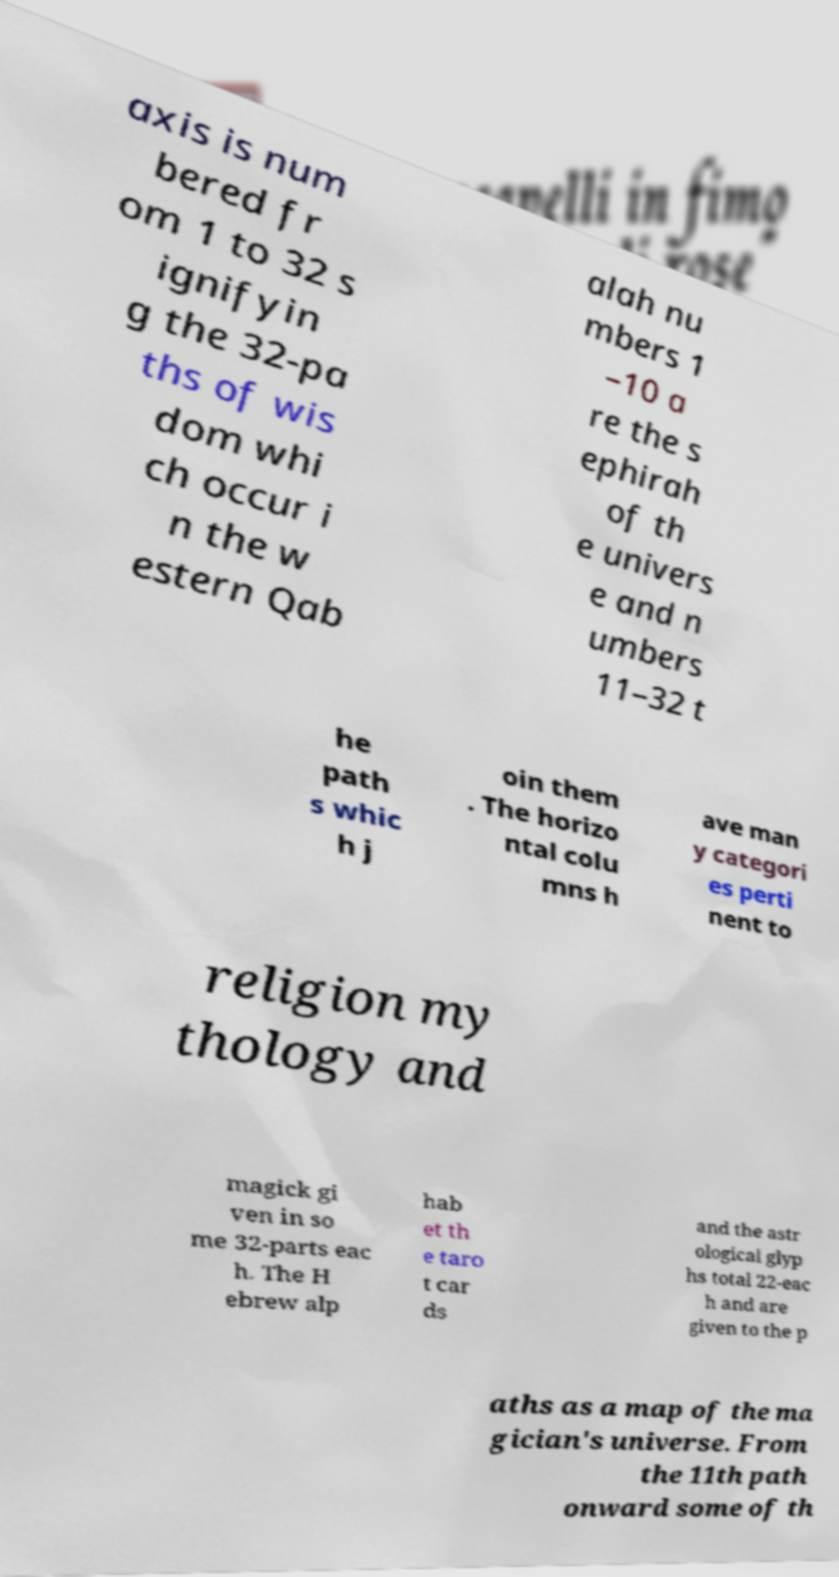I need the written content from this picture converted into text. Can you do that? axis is num bered fr om 1 to 32 s ignifyin g the 32-pa ths of wis dom whi ch occur i n the w estern Qab alah nu mbers 1 –10 a re the s ephirah of th e univers e and n umbers 11–32 t he path s whic h j oin them . The horizo ntal colu mns h ave man y categori es perti nent to religion my thology and magick gi ven in so me 32-parts eac h. The H ebrew alp hab et th e taro t car ds and the astr ological glyp hs total 22-eac h and are given to the p aths as a map of the ma gician's universe. From the 11th path onward some of th 